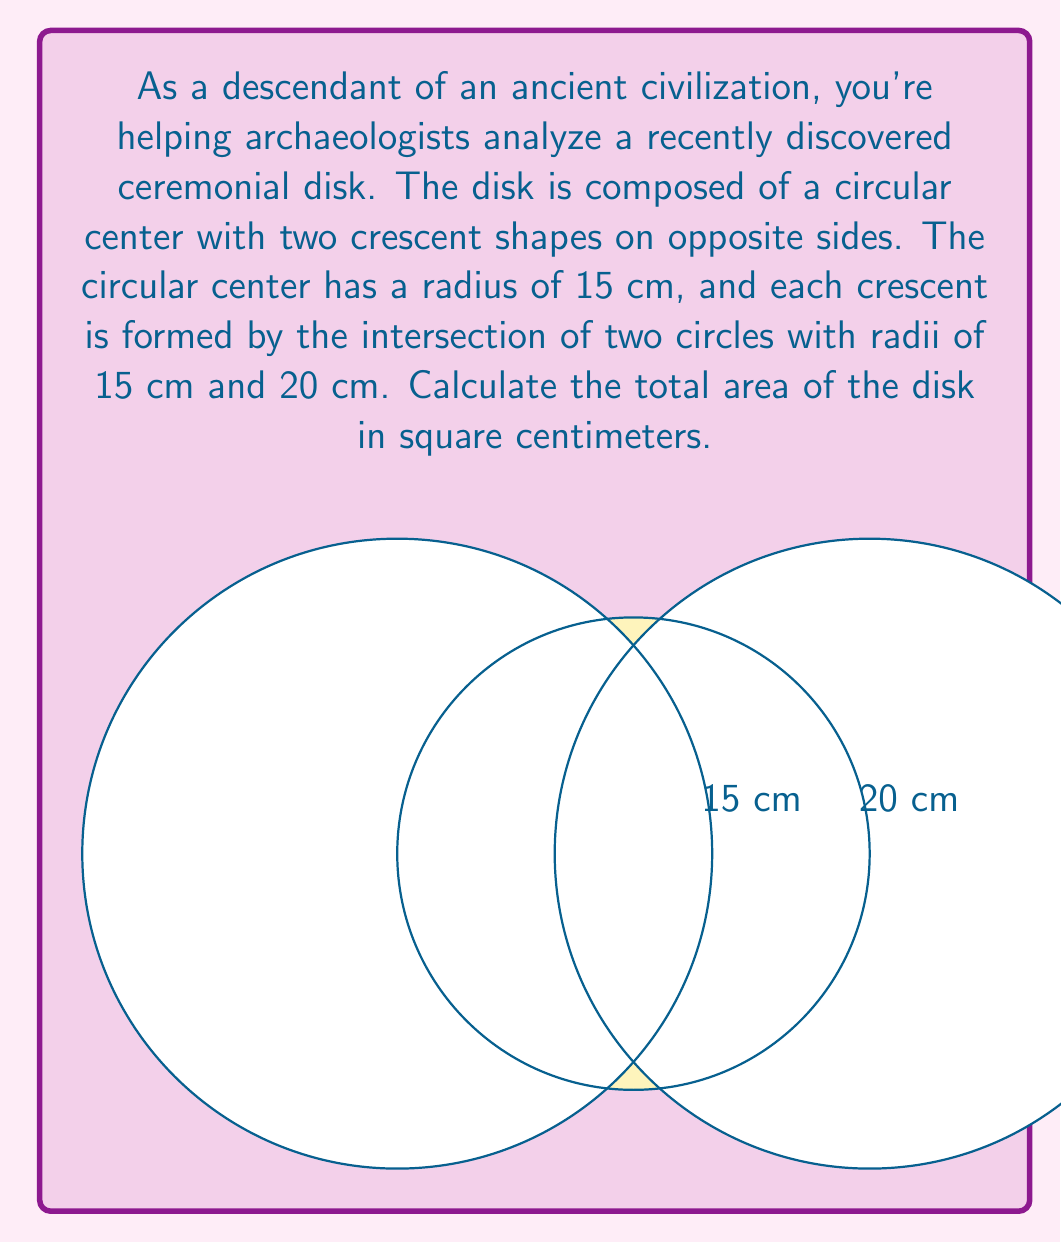Help me with this question. To solve this problem, we need to:
1. Calculate the area of the central circle
2. Calculate the area of one crescent
3. Add the central circle area and twice the crescent area

Step 1: Area of the central circle
The area of a circle is given by $A = \pi r^2$
$$A_{\text{circle}} = \pi (15\text{ cm})^2 = 225\pi \text{ cm}^2$$

Step 2: Area of one crescent
To find the area of one crescent, we need to:
a) Calculate the area of the sector of the larger circle (20 cm radius)
b) Subtract the area of the triangle formed by the center and the intersection points
c) Subtract the area of the smaller circle segment

a) Area of the sector:
First, we need to find the central angle $\theta$ (in radians):
$$\cos(\theta/2) = \frac{15}{20} = 0.75$$
$$\theta/2 = \arccos(0.75) \approx 0.7227$$
$$\theta \approx 1.4454 \text{ radians}$$

The area of the sector is:
$$A_{\text{sector}} = \frac{1}{2} r^2 \theta = \frac{1}{2} (20\text{ cm})^2 (1.4454) \approx 289.08 \text{ cm}^2$$

b) Area of the triangle:
$$A_{\text{triangle}} = \frac{1}{2} (20\text{ cm}) (15\text{ cm}) \sin(1.4454) \approx 141.37 \text{ cm}^2$$

c) Area of the smaller circle segment:
$$A_{\text{segment}} = \frac{1}{2} (15\text{ cm})^2 (1.4454 - \sin(1.4454)) \approx 35.21 \text{ cm}^2$$

The area of one crescent is:
$$A_{\text{crescent}} = A_{\text{sector}} - A_{\text{triangle}} - A_{\text{segment}}$$
$$A_{\text{crescent}} \approx 289.08 - 141.37 - 35.21 = 112.50 \text{ cm}^2$$

Step 3: Total area of the disk
$$A_{\text{total}} = A_{\text{circle}} + 2A_{\text{crescent}}$$
$$A_{\text{total}} = 225\pi + 2(112.50) \approx 931.73 \text{ cm}^2$$
Answer: The total area of the ceremonial disk is approximately 931.73 square centimeters. 